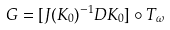<formula> <loc_0><loc_0><loc_500><loc_500>G = [ J ( K _ { 0 } ) ^ { - 1 } D K _ { 0 } ] \circ T _ { \omega }</formula> 